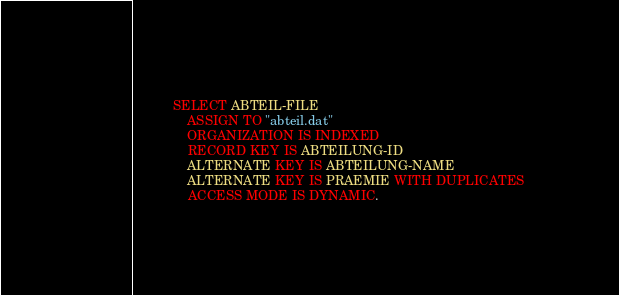<code> <loc_0><loc_0><loc_500><loc_500><_COBOL_>           SELECT ABTEIL-FILE
               ASSIGN TO "abteil.dat"
               ORGANIZATION IS INDEXED
               RECORD KEY IS ABTEILUNG-ID
               ALTERNATE KEY IS ABTEILUNG-NAME
               ALTERNATE KEY IS PRAEMIE WITH DUPLICATES
               ACCESS MODE IS DYNAMIC.
</code> 